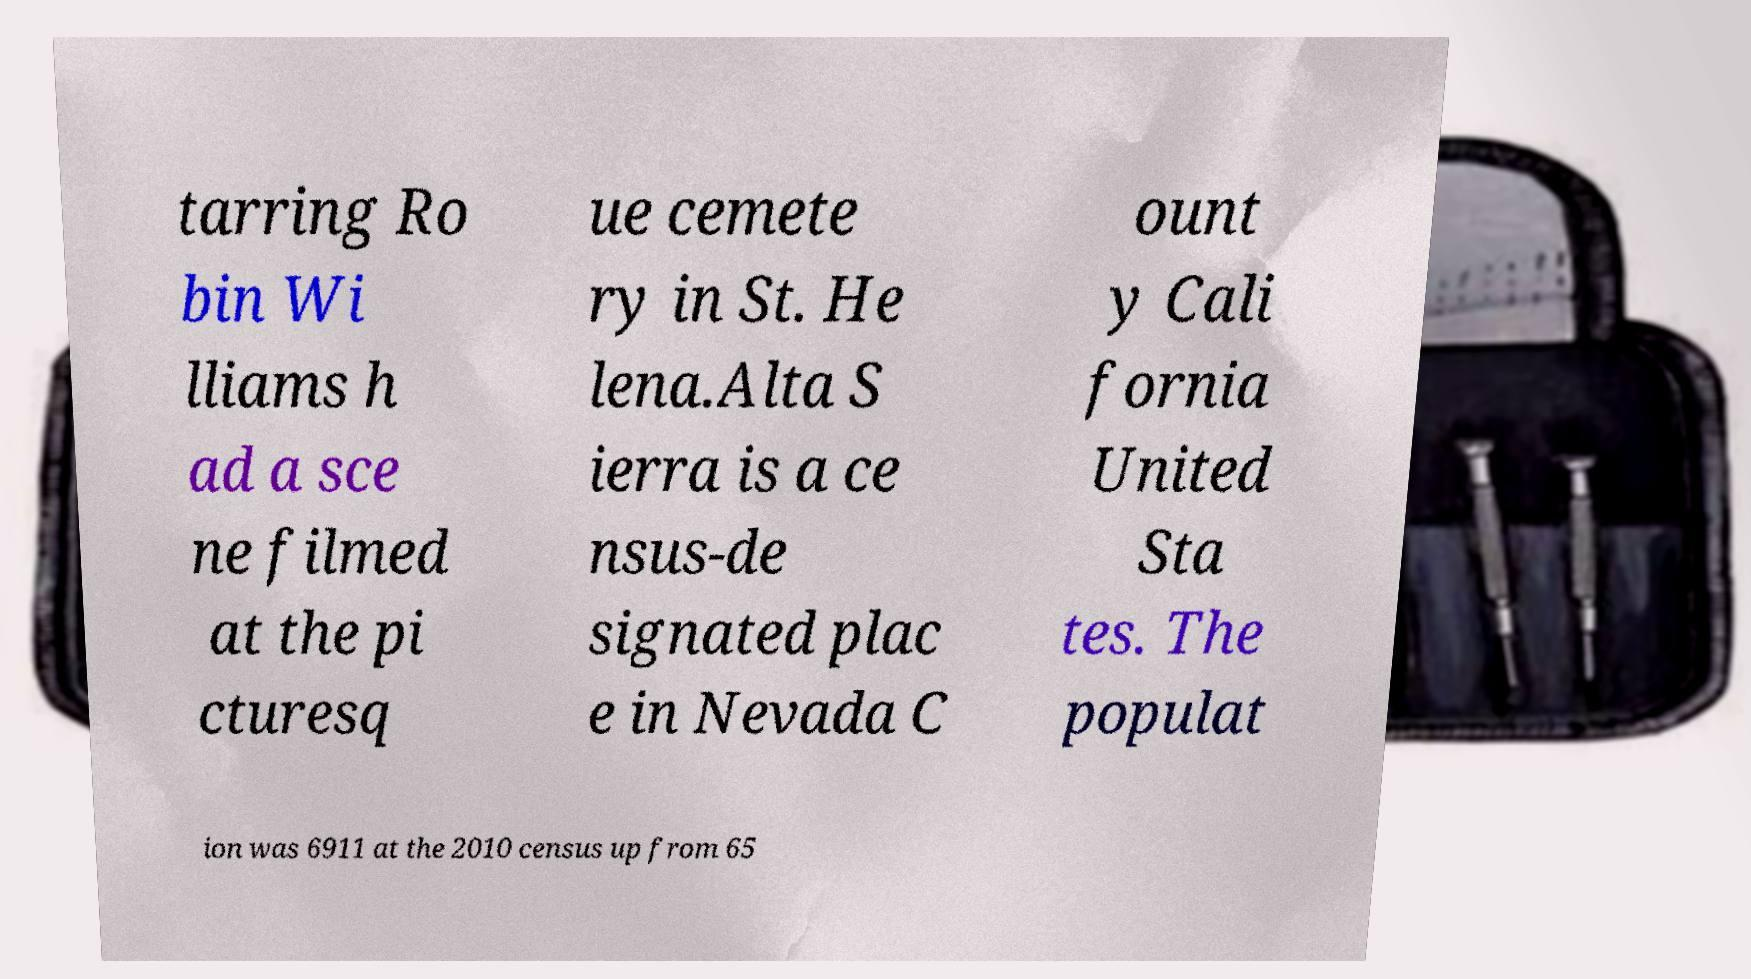Please identify and transcribe the text found in this image. tarring Ro bin Wi lliams h ad a sce ne filmed at the pi cturesq ue cemete ry in St. He lena.Alta S ierra is a ce nsus-de signated plac e in Nevada C ount y Cali fornia United Sta tes. The populat ion was 6911 at the 2010 census up from 65 